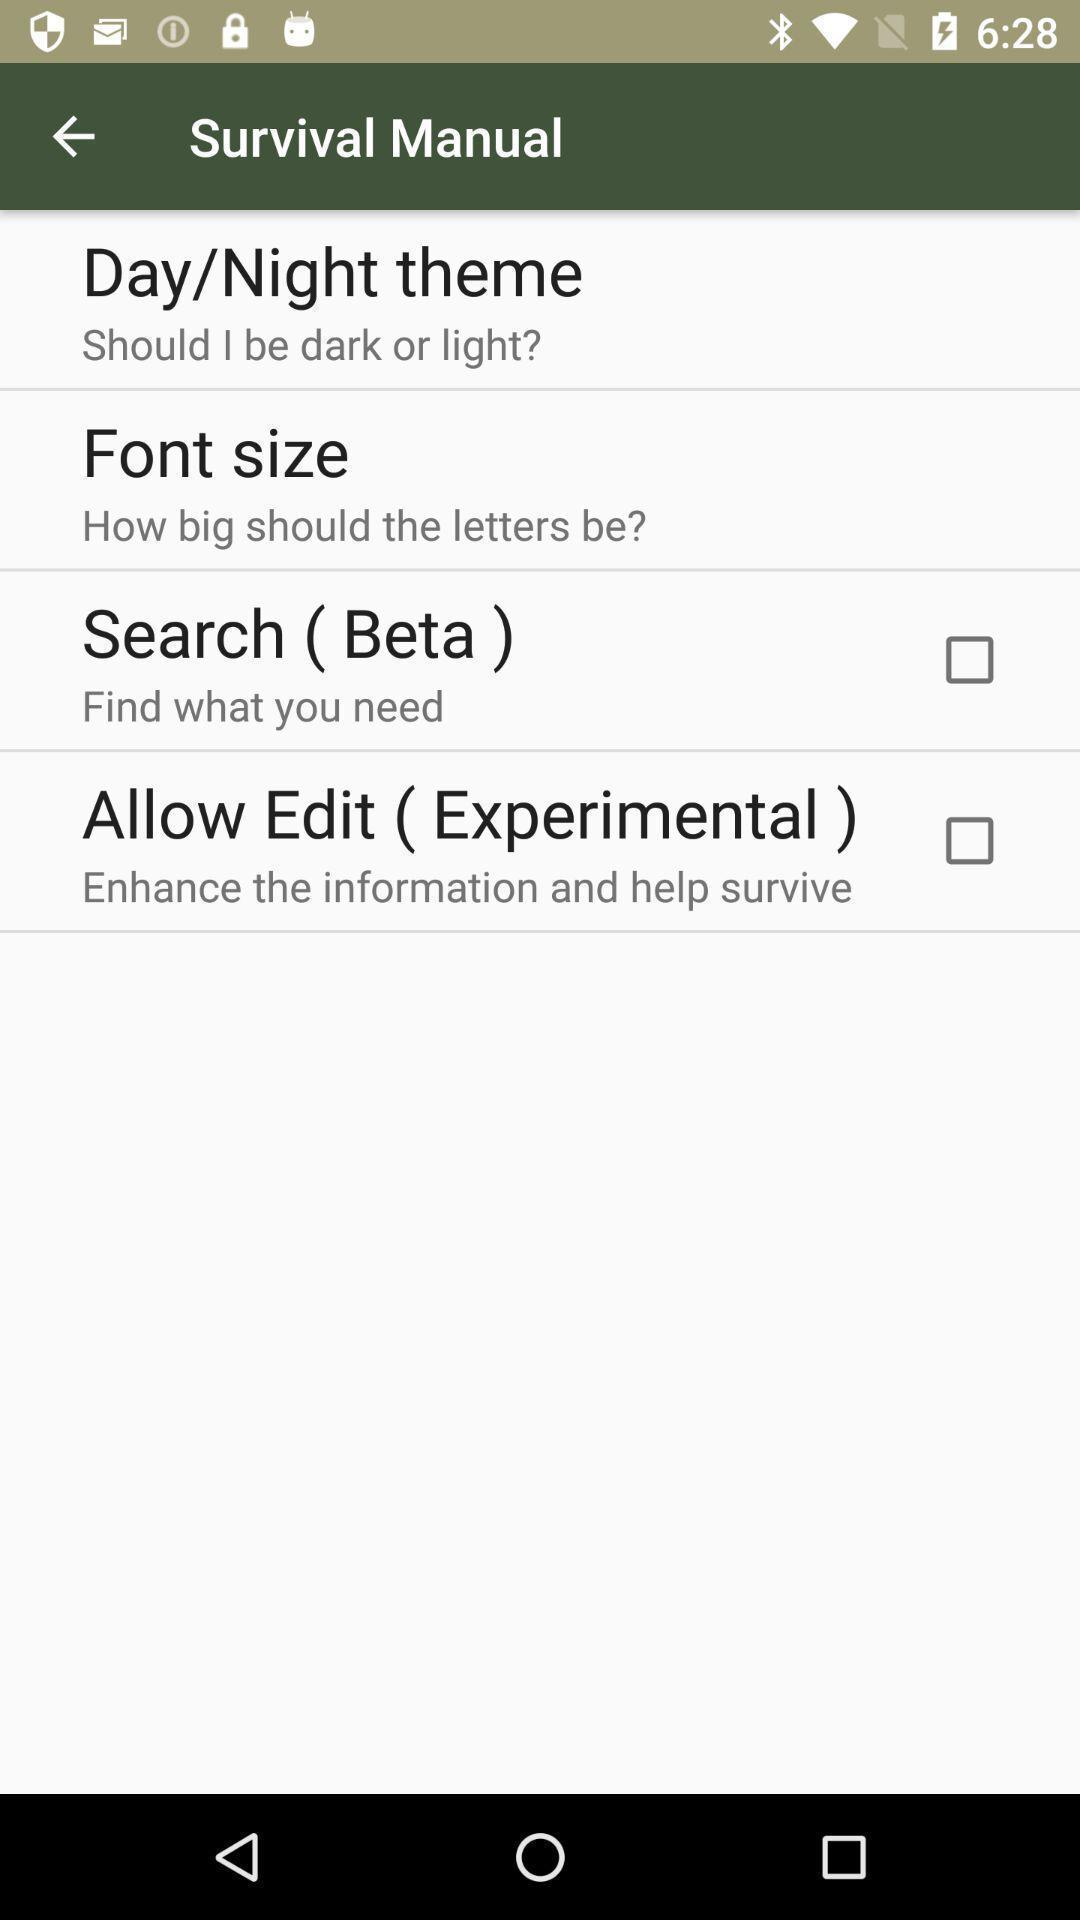Describe the content in this image. Page showing variety of themes. 